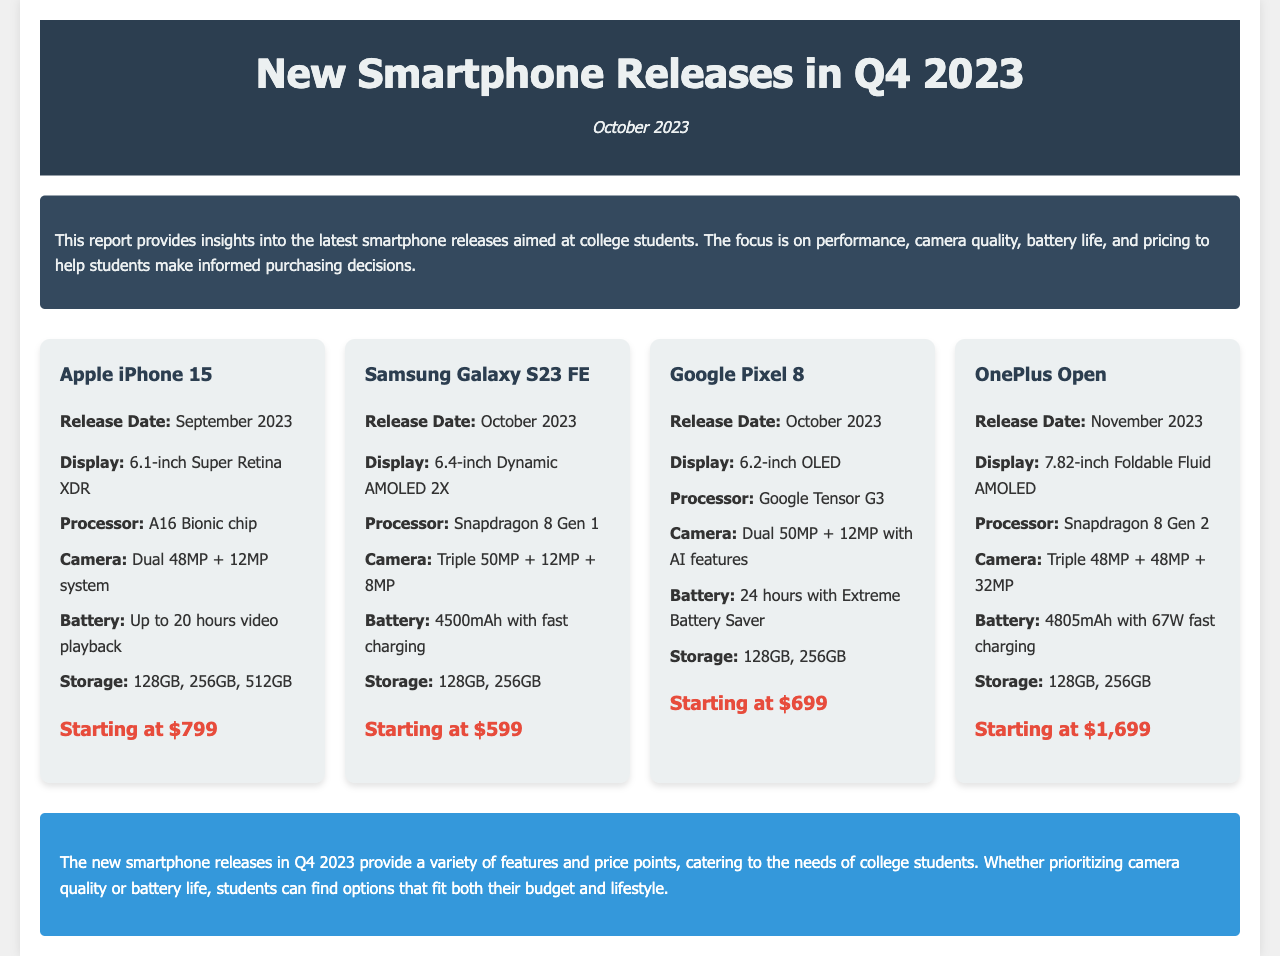what is the release date of the Apple iPhone 15? The release date of the Apple iPhone 15 is mentioned in the document as September 2023.
Answer: September 2023 what is the starting price of the Samsung Galaxy S23 FE? The starting price of the Samsung Galaxy S23 FE is specified in the document.
Answer: $599 how many megapixels is the camera on the Google Pixel 8? The document lists the camera specifications of the Google Pixel 8, which includes dual 50MP + 12MP.
Answer: 50MP + 12MP which smartphone features a foldable display? The document states that the OnePlus Open has a foldable display of 7.82 inches.
Answer: OnePlus Open what battery life does the Google Pixel 8 offer with Extreme Battery Saver? The document indicates the battery life of the Google Pixel 8 with Extreme Battery Saver is 24 hours.
Answer: 24 hours which smartphone is expected to be released in November 2023? The document mentions that the OnePlus Open is set for release in November 2023.
Answer: OnePlus Open what is the processor used in the Samsung Galaxy S23 FE? The document specifies that the processor in the Samsung Galaxy S23 FE is Snapdragon 8 Gen 1.
Answer: Snapdragon 8 Gen 1 list a feature of the Apple iPhone 15 The document describes various features of the Apple iPhone 15, including a dual 48MP + 12MP camera system.
Answer: Dual 48MP + 12MP camera system what percentage of smartphones in this report have a battery life over 20 hours? The document states that both the Google Pixel 8 and the Apple iPhone 15 offer battery life specifications of at least 20 hours. There are 4 smartphones listed, so 50% have that capability.
Answer: 50% 